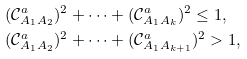Convert formula to latex. <formula><loc_0><loc_0><loc_500><loc_500>& ( \mathcal { C } ^ { a } _ { A _ { 1 } A _ { 2 } } ) ^ { 2 } + \cdots + ( \mathcal { C } ^ { a } _ { A _ { 1 } A _ { k } } ) ^ { 2 } \leq 1 , \\ & ( \mathcal { C } ^ { a } _ { A _ { 1 } A _ { 2 } } ) ^ { 2 } + \cdots + ( \mathcal { C } ^ { a } _ { A _ { 1 } A _ { k + 1 } } ) ^ { 2 } > 1 ,</formula> 